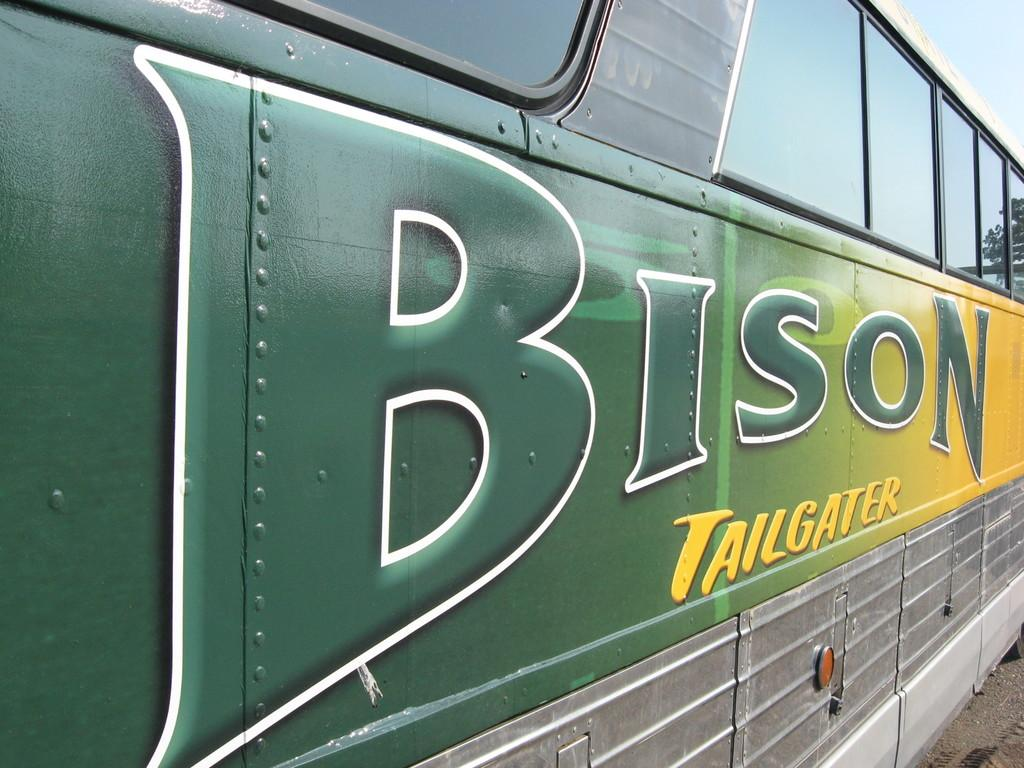<image>
Offer a succinct explanation of the picture presented. A large green and yellow bus has the words Bison Tailgater written on the side 